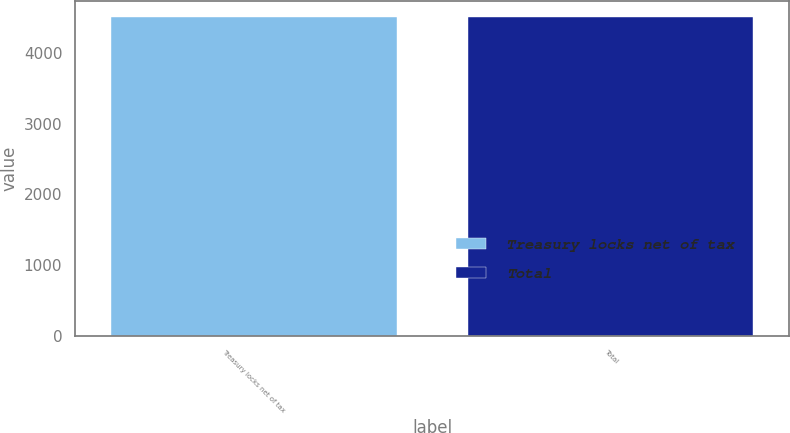Convert chart to OTSL. <chart><loc_0><loc_0><loc_500><loc_500><bar_chart><fcel>Treasury locks net of tax<fcel>Total<nl><fcel>4512<fcel>4512.1<nl></chart> 